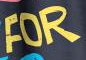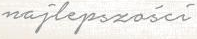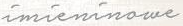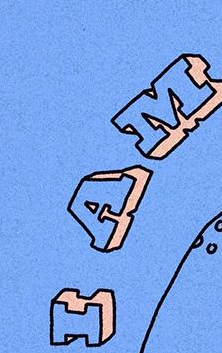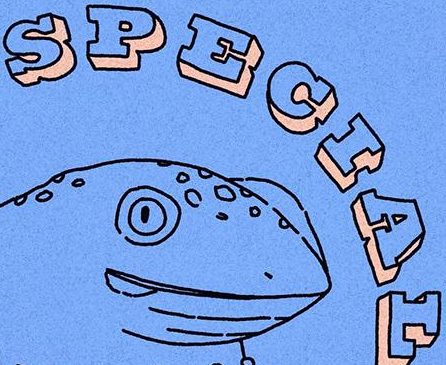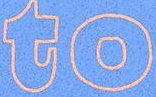What text is displayed in these images sequentially, separated by a semicolon? FOR; najlepszości; imieninowe; IAM; SPECIAL; to 